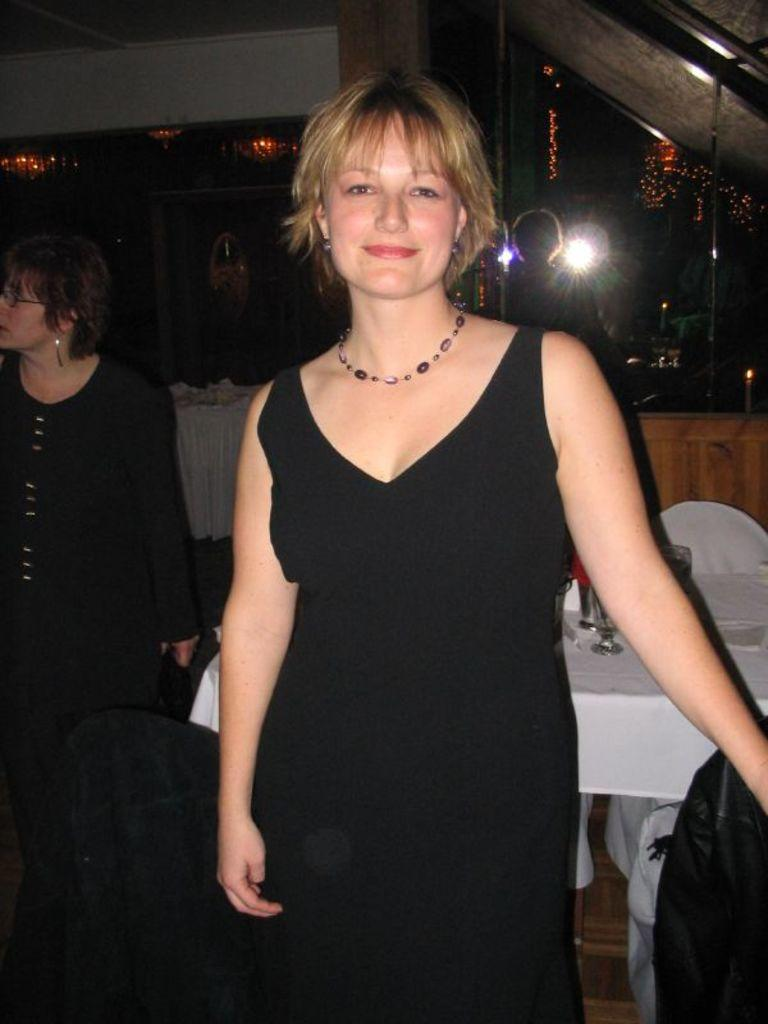How many people are in the image? There are two ladies standing in the image. What can be seen in the background of the image? There are tables and chairs in the background of the image. What objects are placed on the table? Glasses are placed on the table. What is visible on one side of the image? There is a wall visible in the image. What is providing illumination in the image? Lights are present in the image. What type of religious cover is worn by the ladies in the image? There is no religious cover visible in the image; the ladies are not wearing any headwear. 